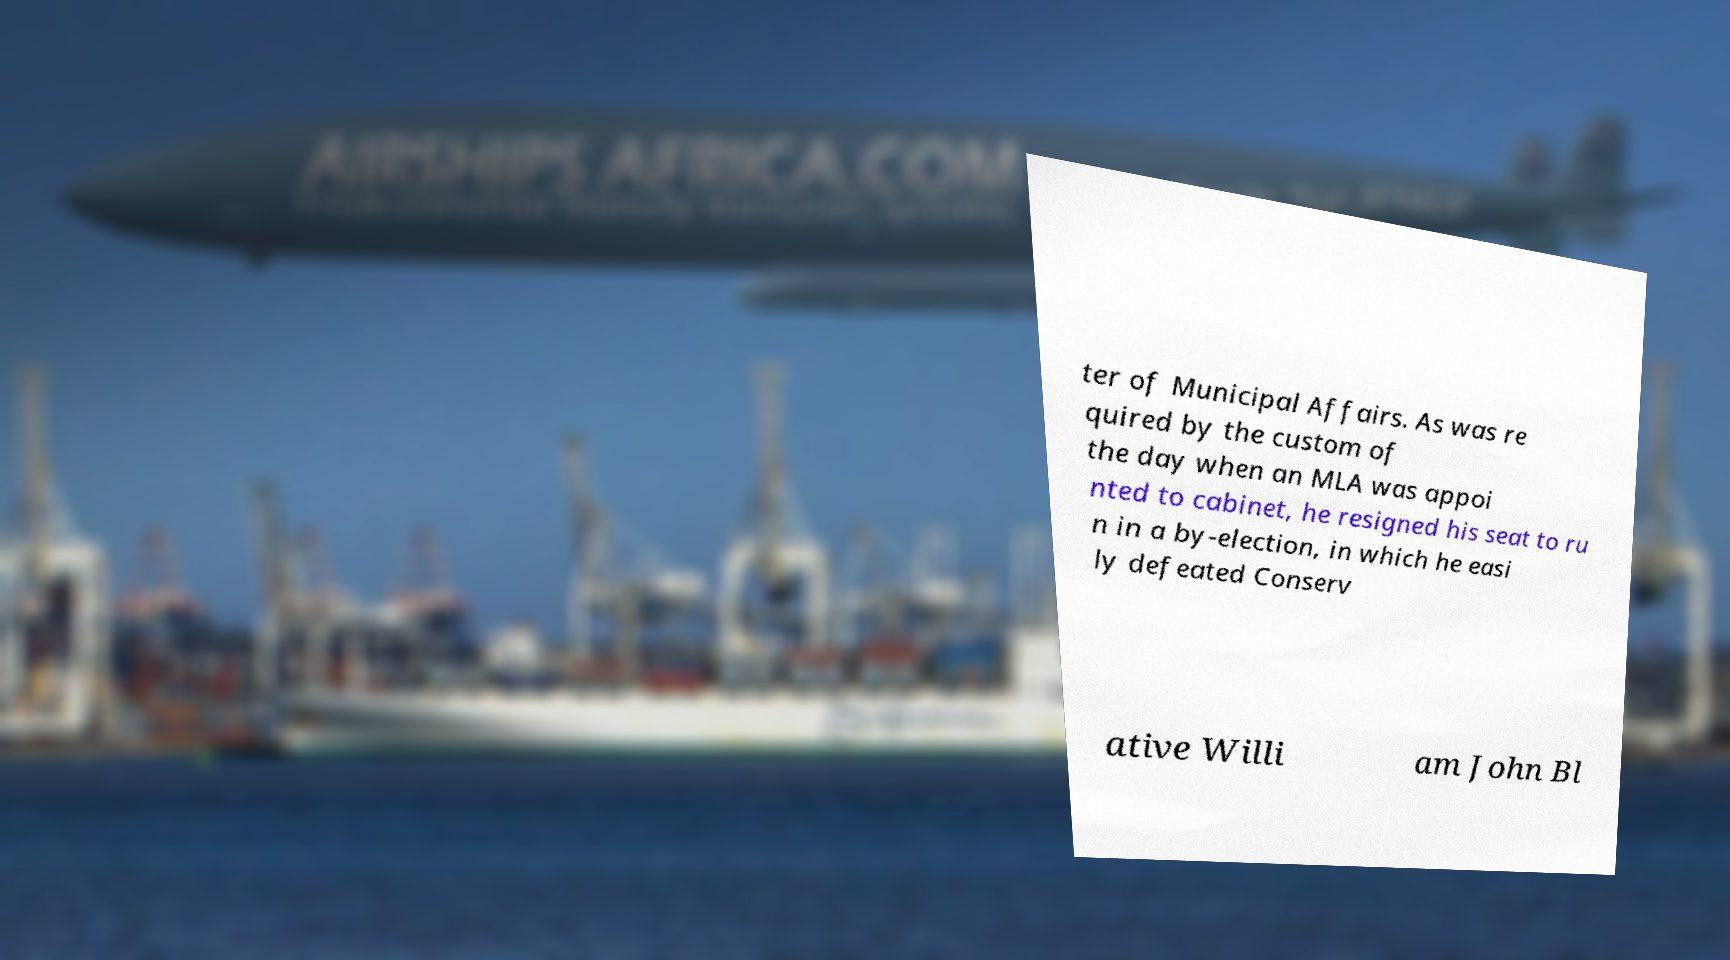What messages or text are displayed in this image? I need them in a readable, typed format. ter of Municipal Affairs. As was re quired by the custom of the day when an MLA was appoi nted to cabinet, he resigned his seat to ru n in a by-election, in which he easi ly defeated Conserv ative Willi am John Bl 